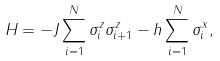Convert formula to latex. <formula><loc_0><loc_0><loc_500><loc_500>H = - J \sum _ { i = 1 } ^ { N } \sigma _ { i } ^ { z } \sigma _ { i + 1 } ^ { z } - h \sum _ { i = 1 } ^ { N } \sigma _ { i } ^ { x } ,</formula> 